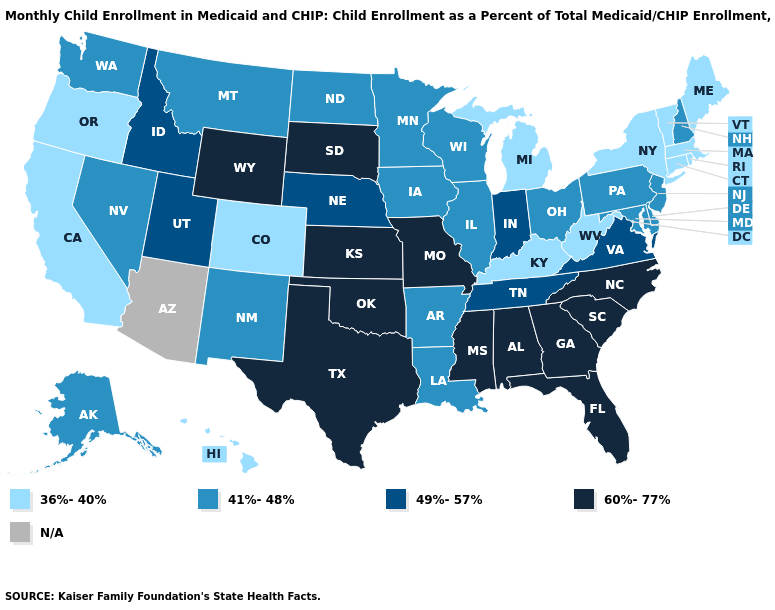What is the lowest value in the USA?
Short answer required. 36%-40%. Name the states that have a value in the range 60%-77%?
Concise answer only. Alabama, Florida, Georgia, Kansas, Mississippi, Missouri, North Carolina, Oklahoma, South Carolina, South Dakota, Texas, Wyoming. What is the value of Texas?
Give a very brief answer. 60%-77%. Which states have the lowest value in the Northeast?
Give a very brief answer. Connecticut, Maine, Massachusetts, New York, Rhode Island, Vermont. Which states have the lowest value in the USA?
Concise answer only. California, Colorado, Connecticut, Hawaii, Kentucky, Maine, Massachusetts, Michigan, New York, Oregon, Rhode Island, Vermont, West Virginia. Does Washington have the lowest value in the West?
Keep it brief. No. Among the states that border Colorado , which have the highest value?
Give a very brief answer. Kansas, Oklahoma, Wyoming. Name the states that have a value in the range N/A?
Short answer required. Arizona. Among the states that border New York , which have the highest value?
Quick response, please. New Jersey, Pennsylvania. What is the value of Nevada?
Be succinct. 41%-48%. Is the legend a continuous bar?
Short answer required. No. How many symbols are there in the legend?
Give a very brief answer. 5. Name the states that have a value in the range 49%-57%?
Be succinct. Idaho, Indiana, Nebraska, Tennessee, Utah, Virginia. Which states have the lowest value in the West?
Short answer required. California, Colorado, Hawaii, Oregon. Among the states that border Oregon , which have the highest value?
Give a very brief answer. Idaho. 